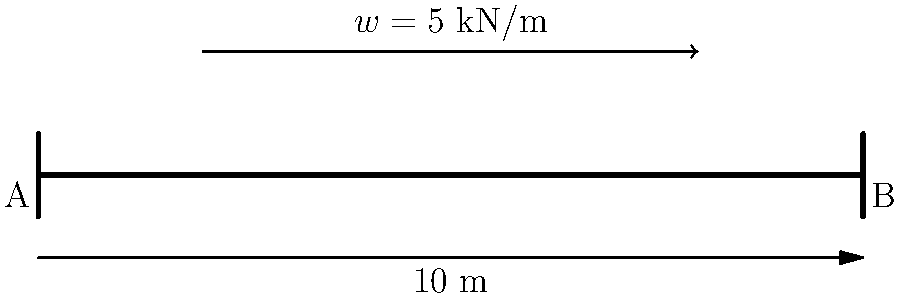Consider a simply supported bridge beam of length 10 m subjected to a uniformly distributed load of 5 kN/m over the middle 6 m, as shown in the figure. Determine the maximum shear force and bending moment in the beam. How might these values influence your recommendations for an energy-boosting diet for construction workers involved in bridge maintenance? Let's approach this step-by-step:

1) First, calculate the total load:
   $W = 5 \text{ kN/m} \times 6 \text{ m} = 30 \text{ kN}$

2) Find the reactions at the supports:
   Due to symmetry, $R_A = R_B = \frac{W}{2} = 15 \text{ kN}$

3) Shear force diagram:
   - From A to start of load: constant 15 kN
   - Under the load: decreases linearly from 15 kN to -15 kN
   - From end of load to B: constant -15 kN

   Maximum shear force = 15 kN

4) Bending moment diagram:
   - Increases from 0 at A to maximum at midspan
   - Decreases symmetrically to 0 at B

   To find the maximum bending moment at midspan:
   $M_{max} = R_A \times 5 \text{ m} - \frac{w \times 3^2}{2} = 15 \times 5 - \frac{5 \times 3^2}{2} = 52.5 \text{ kN·m}$

5) Nutritional perspective:
   Construction workers involved in bridge maintenance, especially those dealing with heavy loads and structural integrity, require a diet that supports sustained energy and muscle function. The high shear forces and bending moments indicate significant stress on the structure, which parallels the physical demands on workers.

   Recommendations might include:
   - Complex carbohydrates for sustained energy (whole grains, legumes)
   - Lean proteins for muscle repair and strength (chicken, fish, lean beef)
   - Omega-3 fatty acids for joint health and inflammation reduction (fatty fish, walnuts)
   - Antioxidant-rich foods to combat oxidative stress from physical labor (berries, leafy greens)
   - Adequate hydration to maintain focus and prevent fatigue

   These dietary strategies can help workers maintain energy levels, support muscle function, and promote overall health, which is crucial when working on structures subjected to high forces and moments.
Answer: Maximum shear force: 15 kN; Maximum bending moment: 52.5 kN·m. Diet: complex carbs, lean proteins, omega-3s, antioxidants, hydration. 